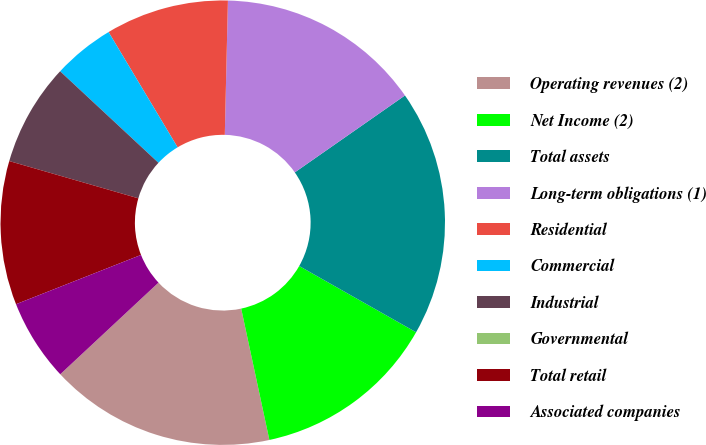<chart> <loc_0><loc_0><loc_500><loc_500><pie_chart><fcel>Operating revenues (2)<fcel>Net Income (2)<fcel>Total assets<fcel>Long-term obligations (1)<fcel>Residential<fcel>Commercial<fcel>Industrial<fcel>Governmental<fcel>Total retail<fcel>Associated companies<nl><fcel>16.42%<fcel>13.43%<fcel>17.91%<fcel>14.93%<fcel>8.96%<fcel>4.48%<fcel>7.46%<fcel>0.0%<fcel>10.45%<fcel>5.97%<nl></chart> 